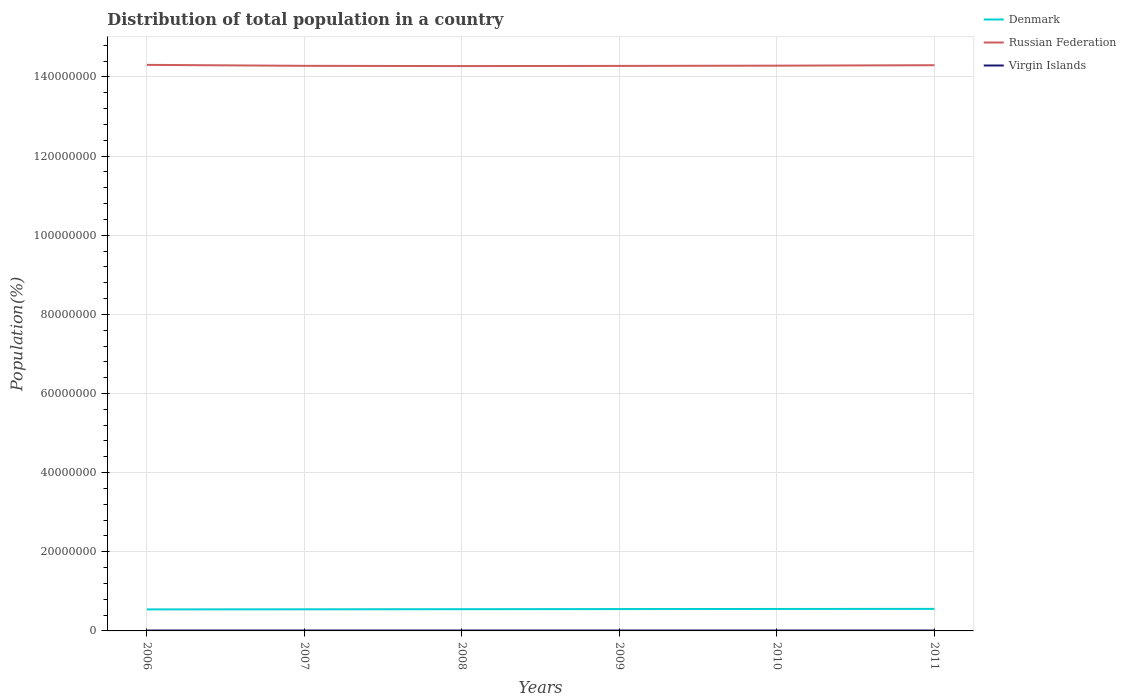How many different coloured lines are there?
Provide a short and direct response. 3. Is the number of lines equal to the number of legend labels?
Provide a short and direct response. Yes. Across all years, what is the maximum population of in Russian Federation?
Your answer should be compact. 1.43e+08. In which year was the population of in Virgin Islands maximum?
Offer a terse response. 2011. What is the total population of in Virgin Islands in the graph?
Your answer should be very brief. 1307. What is the difference between the highest and the second highest population of in Denmark?
Your answer should be very brief. 1.33e+05. What is the difference between the highest and the lowest population of in Denmark?
Your response must be concise. 3. How many lines are there?
Your answer should be very brief. 3. How many years are there in the graph?
Offer a terse response. 6. What is the difference between two consecutive major ticks on the Y-axis?
Ensure brevity in your answer.  2.00e+07. Does the graph contain grids?
Give a very brief answer. Yes. How are the legend labels stacked?
Provide a short and direct response. Vertical. What is the title of the graph?
Your response must be concise. Distribution of total population in a country. Does "Seychelles" appear as one of the legend labels in the graph?
Ensure brevity in your answer.  No. What is the label or title of the Y-axis?
Ensure brevity in your answer.  Population(%). What is the Population(%) in Denmark in 2006?
Provide a succinct answer. 5.44e+06. What is the Population(%) in Russian Federation in 2006?
Keep it short and to the point. 1.43e+08. What is the Population(%) of Virgin Islands in 2006?
Provide a short and direct response. 1.08e+05. What is the Population(%) in Denmark in 2007?
Your answer should be compact. 5.46e+06. What is the Population(%) of Russian Federation in 2007?
Provide a short and direct response. 1.43e+08. What is the Population(%) of Virgin Islands in 2007?
Offer a terse response. 1.07e+05. What is the Population(%) in Denmark in 2008?
Your answer should be compact. 5.49e+06. What is the Population(%) of Russian Federation in 2008?
Offer a very short reply. 1.43e+08. What is the Population(%) in Virgin Islands in 2008?
Give a very brief answer. 1.07e+05. What is the Population(%) in Denmark in 2009?
Keep it short and to the point. 5.52e+06. What is the Population(%) in Russian Federation in 2009?
Offer a very short reply. 1.43e+08. What is the Population(%) of Virgin Islands in 2009?
Keep it short and to the point. 1.07e+05. What is the Population(%) of Denmark in 2010?
Your answer should be compact. 5.55e+06. What is the Population(%) of Russian Federation in 2010?
Give a very brief answer. 1.43e+08. What is the Population(%) of Virgin Islands in 2010?
Offer a very short reply. 1.06e+05. What is the Population(%) of Denmark in 2011?
Provide a succinct answer. 5.57e+06. What is the Population(%) of Russian Federation in 2011?
Your answer should be very brief. 1.43e+08. What is the Population(%) of Virgin Islands in 2011?
Offer a terse response. 1.06e+05. Across all years, what is the maximum Population(%) in Denmark?
Keep it short and to the point. 5.57e+06. Across all years, what is the maximum Population(%) in Russian Federation?
Ensure brevity in your answer.  1.43e+08. Across all years, what is the maximum Population(%) in Virgin Islands?
Offer a terse response. 1.08e+05. Across all years, what is the minimum Population(%) in Denmark?
Offer a very short reply. 5.44e+06. Across all years, what is the minimum Population(%) in Russian Federation?
Your response must be concise. 1.43e+08. Across all years, what is the minimum Population(%) in Virgin Islands?
Your response must be concise. 1.06e+05. What is the total Population(%) of Denmark in the graph?
Offer a terse response. 3.30e+07. What is the total Population(%) in Russian Federation in the graph?
Offer a very short reply. 8.57e+08. What is the total Population(%) of Virgin Islands in the graph?
Offer a very short reply. 6.41e+05. What is the difference between the Population(%) of Denmark in 2006 and that in 2007?
Ensure brevity in your answer.  -2.42e+04. What is the difference between the Population(%) of Russian Federation in 2006 and that in 2007?
Offer a very short reply. 2.44e+05. What is the difference between the Population(%) in Virgin Islands in 2006 and that in 2007?
Make the answer very short. 277. What is the difference between the Population(%) of Denmark in 2006 and that in 2008?
Offer a very short reply. -5.63e+04. What is the difference between the Population(%) of Russian Federation in 2006 and that in 2008?
Your answer should be very brief. 3.07e+05. What is the difference between the Population(%) of Virgin Islands in 2006 and that in 2008?
Your answer should be compact. 609. What is the difference between the Population(%) in Denmark in 2006 and that in 2009?
Your answer should be very brief. -8.58e+04. What is the difference between the Population(%) of Russian Federation in 2006 and that in 2009?
Offer a terse response. 2.64e+05. What is the difference between the Population(%) of Virgin Islands in 2006 and that in 2009?
Your answer should be very brief. 993. What is the difference between the Population(%) of Denmark in 2006 and that in 2010?
Your answer should be compact. -1.10e+05. What is the difference between the Population(%) of Russian Federation in 2006 and that in 2010?
Make the answer very short. 2.00e+05. What is the difference between the Population(%) in Virgin Islands in 2006 and that in 2010?
Give a very brief answer. 1433. What is the difference between the Population(%) in Denmark in 2006 and that in 2011?
Provide a succinct answer. -1.33e+05. What is the difference between the Population(%) in Russian Federation in 2006 and that in 2011?
Provide a short and direct response. 8.87e+04. What is the difference between the Population(%) in Virgin Islands in 2006 and that in 2011?
Offer a very short reply. 1916. What is the difference between the Population(%) of Denmark in 2007 and that in 2008?
Your response must be concise. -3.22e+04. What is the difference between the Population(%) of Russian Federation in 2007 and that in 2008?
Offer a very short reply. 6.27e+04. What is the difference between the Population(%) in Virgin Islands in 2007 and that in 2008?
Give a very brief answer. 332. What is the difference between the Population(%) of Denmark in 2007 and that in 2009?
Make the answer very short. -6.17e+04. What is the difference between the Population(%) of Russian Federation in 2007 and that in 2009?
Give a very brief answer. 1.97e+04. What is the difference between the Population(%) in Virgin Islands in 2007 and that in 2009?
Offer a very short reply. 716. What is the difference between the Population(%) in Denmark in 2007 and that in 2010?
Your response must be concise. -8.62e+04. What is the difference between the Population(%) in Russian Federation in 2007 and that in 2010?
Make the answer very short. -4.44e+04. What is the difference between the Population(%) of Virgin Islands in 2007 and that in 2010?
Give a very brief answer. 1156. What is the difference between the Population(%) of Denmark in 2007 and that in 2011?
Ensure brevity in your answer.  -1.09e+05. What is the difference between the Population(%) in Russian Federation in 2007 and that in 2011?
Your answer should be compact. -1.56e+05. What is the difference between the Population(%) in Virgin Islands in 2007 and that in 2011?
Your answer should be compact. 1639. What is the difference between the Population(%) in Denmark in 2008 and that in 2009?
Offer a very short reply. -2.95e+04. What is the difference between the Population(%) in Russian Federation in 2008 and that in 2009?
Provide a succinct answer. -4.30e+04. What is the difference between the Population(%) of Virgin Islands in 2008 and that in 2009?
Your response must be concise. 384. What is the difference between the Population(%) in Denmark in 2008 and that in 2010?
Provide a succinct answer. -5.41e+04. What is the difference between the Population(%) of Russian Federation in 2008 and that in 2010?
Offer a terse response. -1.07e+05. What is the difference between the Population(%) of Virgin Islands in 2008 and that in 2010?
Your response must be concise. 824. What is the difference between the Population(%) in Denmark in 2008 and that in 2011?
Make the answer very short. -7.70e+04. What is the difference between the Population(%) in Russian Federation in 2008 and that in 2011?
Make the answer very short. -2.19e+05. What is the difference between the Population(%) in Virgin Islands in 2008 and that in 2011?
Your answer should be very brief. 1307. What is the difference between the Population(%) of Denmark in 2009 and that in 2010?
Ensure brevity in your answer.  -2.46e+04. What is the difference between the Population(%) in Russian Federation in 2009 and that in 2010?
Your answer should be very brief. -6.41e+04. What is the difference between the Population(%) in Virgin Islands in 2009 and that in 2010?
Provide a succinct answer. 440. What is the difference between the Population(%) in Denmark in 2009 and that in 2011?
Your answer should be compact. -4.75e+04. What is the difference between the Population(%) in Russian Federation in 2009 and that in 2011?
Make the answer very short. -1.76e+05. What is the difference between the Population(%) of Virgin Islands in 2009 and that in 2011?
Your answer should be very brief. 923. What is the difference between the Population(%) of Denmark in 2010 and that in 2011?
Offer a very short reply. -2.29e+04. What is the difference between the Population(%) in Russian Federation in 2010 and that in 2011?
Your answer should be very brief. -1.11e+05. What is the difference between the Population(%) of Virgin Islands in 2010 and that in 2011?
Your answer should be compact. 483. What is the difference between the Population(%) of Denmark in 2006 and the Population(%) of Russian Federation in 2007?
Offer a very short reply. -1.37e+08. What is the difference between the Population(%) in Denmark in 2006 and the Population(%) in Virgin Islands in 2007?
Your answer should be very brief. 5.33e+06. What is the difference between the Population(%) in Russian Federation in 2006 and the Population(%) in Virgin Islands in 2007?
Ensure brevity in your answer.  1.43e+08. What is the difference between the Population(%) in Denmark in 2006 and the Population(%) in Russian Federation in 2008?
Provide a short and direct response. -1.37e+08. What is the difference between the Population(%) of Denmark in 2006 and the Population(%) of Virgin Islands in 2008?
Make the answer very short. 5.33e+06. What is the difference between the Population(%) in Russian Federation in 2006 and the Population(%) in Virgin Islands in 2008?
Make the answer very short. 1.43e+08. What is the difference between the Population(%) of Denmark in 2006 and the Population(%) of Russian Federation in 2009?
Give a very brief answer. -1.37e+08. What is the difference between the Population(%) in Denmark in 2006 and the Population(%) in Virgin Islands in 2009?
Offer a very short reply. 5.33e+06. What is the difference between the Population(%) of Russian Federation in 2006 and the Population(%) of Virgin Islands in 2009?
Ensure brevity in your answer.  1.43e+08. What is the difference between the Population(%) in Denmark in 2006 and the Population(%) in Russian Federation in 2010?
Ensure brevity in your answer.  -1.37e+08. What is the difference between the Population(%) of Denmark in 2006 and the Population(%) of Virgin Islands in 2010?
Provide a succinct answer. 5.33e+06. What is the difference between the Population(%) of Russian Federation in 2006 and the Population(%) of Virgin Islands in 2010?
Your answer should be very brief. 1.43e+08. What is the difference between the Population(%) in Denmark in 2006 and the Population(%) in Russian Federation in 2011?
Your response must be concise. -1.38e+08. What is the difference between the Population(%) in Denmark in 2006 and the Population(%) in Virgin Islands in 2011?
Give a very brief answer. 5.33e+06. What is the difference between the Population(%) of Russian Federation in 2006 and the Population(%) of Virgin Islands in 2011?
Your response must be concise. 1.43e+08. What is the difference between the Population(%) in Denmark in 2007 and the Population(%) in Russian Federation in 2008?
Your response must be concise. -1.37e+08. What is the difference between the Population(%) of Denmark in 2007 and the Population(%) of Virgin Islands in 2008?
Offer a very short reply. 5.35e+06. What is the difference between the Population(%) of Russian Federation in 2007 and the Population(%) of Virgin Islands in 2008?
Keep it short and to the point. 1.43e+08. What is the difference between the Population(%) in Denmark in 2007 and the Population(%) in Russian Federation in 2009?
Offer a terse response. -1.37e+08. What is the difference between the Population(%) of Denmark in 2007 and the Population(%) of Virgin Islands in 2009?
Offer a very short reply. 5.35e+06. What is the difference between the Population(%) of Russian Federation in 2007 and the Population(%) of Virgin Islands in 2009?
Ensure brevity in your answer.  1.43e+08. What is the difference between the Population(%) of Denmark in 2007 and the Population(%) of Russian Federation in 2010?
Give a very brief answer. -1.37e+08. What is the difference between the Population(%) of Denmark in 2007 and the Population(%) of Virgin Islands in 2010?
Provide a succinct answer. 5.36e+06. What is the difference between the Population(%) of Russian Federation in 2007 and the Population(%) of Virgin Islands in 2010?
Give a very brief answer. 1.43e+08. What is the difference between the Population(%) of Denmark in 2007 and the Population(%) of Russian Federation in 2011?
Your answer should be compact. -1.37e+08. What is the difference between the Population(%) of Denmark in 2007 and the Population(%) of Virgin Islands in 2011?
Ensure brevity in your answer.  5.36e+06. What is the difference between the Population(%) in Russian Federation in 2007 and the Population(%) in Virgin Islands in 2011?
Give a very brief answer. 1.43e+08. What is the difference between the Population(%) of Denmark in 2008 and the Population(%) of Russian Federation in 2009?
Make the answer very short. -1.37e+08. What is the difference between the Population(%) of Denmark in 2008 and the Population(%) of Virgin Islands in 2009?
Provide a succinct answer. 5.39e+06. What is the difference between the Population(%) in Russian Federation in 2008 and the Population(%) in Virgin Islands in 2009?
Offer a very short reply. 1.43e+08. What is the difference between the Population(%) in Denmark in 2008 and the Population(%) in Russian Federation in 2010?
Your answer should be very brief. -1.37e+08. What is the difference between the Population(%) of Denmark in 2008 and the Population(%) of Virgin Islands in 2010?
Your response must be concise. 5.39e+06. What is the difference between the Population(%) of Russian Federation in 2008 and the Population(%) of Virgin Islands in 2010?
Offer a very short reply. 1.43e+08. What is the difference between the Population(%) of Denmark in 2008 and the Population(%) of Russian Federation in 2011?
Provide a short and direct response. -1.37e+08. What is the difference between the Population(%) of Denmark in 2008 and the Population(%) of Virgin Islands in 2011?
Offer a terse response. 5.39e+06. What is the difference between the Population(%) of Russian Federation in 2008 and the Population(%) of Virgin Islands in 2011?
Your answer should be compact. 1.43e+08. What is the difference between the Population(%) in Denmark in 2009 and the Population(%) in Russian Federation in 2010?
Provide a short and direct response. -1.37e+08. What is the difference between the Population(%) of Denmark in 2009 and the Population(%) of Virgin Islands in 2010?
Give a very brief answer. 5.42e+06. What is the difference between the Population(%) in Russian Federation in 2009 and the Population(%) in Virgin Islands in 2010?
Offer a very short reply. 1.43e+08. What is the difference between the Population(%) in Denmark in 2009 and the Population(%) in Russian Federation in 2011?
Offer a very short reply. -1.37e+08. What is the difference between the Population(%) of Denmark in 2009 and the Population(%) of Virgin Islands in 2011?
Offer a very short reply. 5.42e+06. What is the difference between the Population(%) in Russian Federation in 2009 and the Population(%) in Virgin Islands in 2011?
Offer a terse response. 1.43e+08. What is the difference between the Population(%) in Denmark in 2010 and the Population(%) in Russian Federation in 2011?
Provide a short and direct response. -1.37e+08. What is the difference between the Population(%) in Denmark in 2010 and the Population(%) in Virgin Islands in 2011?
Give a very brief answer. 5.44e+06. What is the difference between the Population(%) in Russian Federation in 2010 and the Population(%) in Virgin Islands in 2011?
Your response must be concise. 1.43e+08. What is the average Population(%) of Denmark per year?
Your answer should be compact. 5.51e+06. What is the average Population(%) of Russian Federation per year?
Offer a very short reply. 1.43e+08. What is the average Population(%) in Virgin Islands per year?
Provide a short and direct response. 1.07e+05. In the year 2006, what is the difference between the Population(%) of Denmark and Population(%) of Russian Federation?
Your answer should be very brief. -1.38e+08. In the year 2006, what is the difference between the Population(%) of Denmark and Population(%) of Virgin Islands?
Make the answer very short. 5.33e+06. In the year 2006, what is the difference between the Population(%) of Russian Federation and Population(%) of Virgin Islands?
Provide a succinct answer. 1.43e+08. In the year 2007, what is the difference between the Population(%) in Denmark and Population(%) in Russian Federation?
Give a very brief answer. -1.37e+08. In the year 2007, what is the difference between the Population(%) in Denmark and Population(%) in Virgin Islands?
Provide a succinct answer. 5.35e+06. In the year 2007, what is the difference between the Population(%) of Russian Federation and Population(%) of Virgin Islands?
Your answer should be compact. 1.43e+08. In the year 2008, what is the difference between the Population(%) in Denmark and Population(%) in Russian Federation?
Your response must be concise. -1.37e+08. In the year 2008, what is the difference between the Population(%) of Denmark and Population(%) of Virgin Islands?
Make the answer very short. 5.39e+06. In the year 2008, what is the difference between the Population(%) in Russian Federation and Population(%) in Virgin Islands?
Offer a very short reply. 1.43e+08. In the year 2009, what is the difference between the Population(%) of Denmark and Population(%) of Russian Federation?
Keep it short and to the point. -1.37e+08. In the year 2009, what is the difference between the Population(%) of Denmark and Population(%) of Virgin Islands?
Your answer should be compact. 5.42e+06. In the year 2009, what is the difference between the Population(%) of Russian Federation and Population(%) of Virgin Islands?
Offer a terse response. 1.43e+08. In the year 2010, what is the difference between the Population(%) of Denmark and Population(%) of Russian Federation?
Keep it short and to the point. -1.37e+08. In the year 2010, what is the difference between the Population(%) in Denmark and Population(%) in Virgin Islands?
Offer a terse response. 5.44e+06. In the year 2010, what is the difference between the Population(%) in Russian Federation and Population(%) in Virgin Islands?
Your answer should be compact. 1.43e+08. In the year 2011, what is the difference between the Population(%) in Denmark and Population(%) in Russian Federation?
Ensure brevity in your answer.  -1.37e+08. In the year 2011, what is the difference between the Population(%) in Denmark and Population(%) in Virgin Islands?
Offer a terse response. 5.46e+06. In the year 2011, what is the difference between the Population(%) in Russian Federation and Population(%) in Virgin Islands?
Ensure brevity in your answer.  1.43e+08. What is the ratio of the Population(%) of Denmark in 2006 to that in 2007?
Make the answer very short. 1. What is the ratio of the Population(%) of Russian Federation in 2006 to that in 2007?
Give a very brief answer. 1. What is the ratio of the Population(%) of Denmark in 2006 to that in 2008?
Keep it short and to the point. 0.99. What is the ratio of the Population(%) in Virgin Islands in 2006 to that in 2008?
Give a very brief answer. 1.01. What is the ratio of the Population(%) in Denmark in 2006 to that in 2009?
Keep it short and to the point. 0.98. What is the ratio of the Population(%) in Virgin Islands in 2006 to that in 2009?
Ensure brevity in your answer.  1.01. What is the ratio of the Population(%) of Denmark in 2006 to that in 2010?
Provide a succinct answer. 0.98. What is the ratio of the Population(%) of Russian Federation in 2006 to that in 2010?
Ensure brevity in your answer.  1. What is the ratio of the Population(%) in Virgin Islands in 2006 to that in 2010?
Provide a succinct answer. 1.01. What is the ratio of the Population(%) of Denmark in 2006 to that in 2011?
Keep it short and to the point. 0.98. What is the ratio of the Population(%) of Virgin Islands in 2006 to that in 2011?
Make the answer very short. 1.02. What is the ratio of the Population(%) in Denmark in 2007 to that in 2009?
Offer a terse response. 0.99. What is the ratio of the Population(%) in Virgin Islands in 2007 to that in 2009?
Your answer should be very brief. 1.01. What is the ratio of the Population(%) of Denmark in 2007 to that in 2010?
Provide a short and direct response. 0.98. What is the ratio of the Population(%) of Russian Federation in 2007 to that in 2010?
Your answer should be compact. 1. What is the ratio of the Population(%) of Virgin Islands in 2007 to that in 2010?
Make the answer very short. 1.01. What is the ratio of the Population(%) of Denmark in 2007 to that in 2011?
Provide a short and direct response. 0.98. What is the ratio of the Population(%) of Russian Federation in 2007 to that in 2011?
Your response must be concise. 1. What is the ratio of the Population(%) in Virgin Islands in 2007 to that in 2011?
Your response must be concise. 1.02. What is the ratio of the Population(%) in Virgin Islands in 2008 to that in 2009?
Ensure brevity in your answer.  1. What is the ratio of the Population(%) in Denmark in 2008 to that in 2010?
Give a very brief answer. 0.99. What is the ratio of the Population(%) of Denmark in 2008 to that in 2011?
Offer a very short reply. 0.99. What is the ratio of the Population(%) of Virgin Islands in 2008 to that in 2011?
Your answer should be compact. 1.01. What is the ratio of the Population(%) in Russian Federation in 2009 to that in 2011?
Provide a short and direct response. 1. What is the ratio of the Population(%) in Virgin Islands in 2009 to that in 2011?
Ensure brevity in your answer.  1.01. What is the ratio of the Population(%) in Russian Federation in 2010 to that in 2011?
Provide a succinct answer. 1. What is the difference between the highest and the second highest Population(%) of Denmark?
Give a very brief answer. 2.29e+04. What is the difference between the highest and the second highest Population(%) in Russian Federation?
Your response must be concise. 8.87e+04. What is the difference between the highest and the second highest Population(%) of Virgin Islands?
Offer a very short reply. 277. What is the difference between the highest and the lowest Population(%) of Denmark?
Provide a short and direct response. 1.33e+05. What is the difference between the highest and the lowest Population(%) in Russian Federation?
Offer a terse response. 3.07e+05. What is the difference between the highest and the lowest Population(%) of Virgin Islands?
Provide a short and direct response. 1916. 